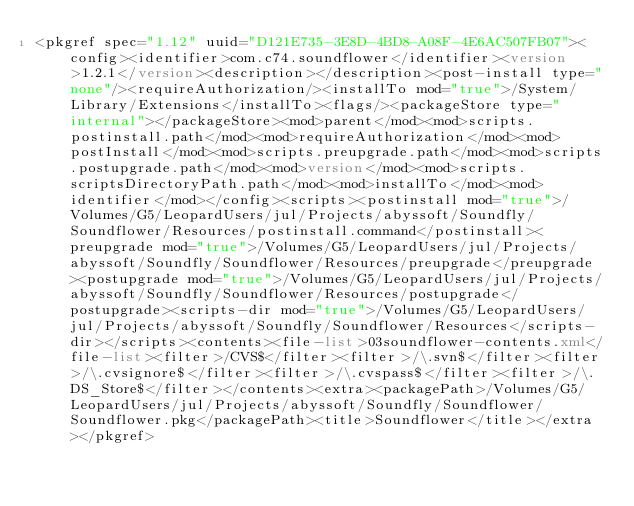<code> <loc_0><loc_0><loc_500><loc_500><_XML_><pkgref spec="1.12" uuid="D121E735-3E8D-4BD8-A08F-4E6AC507FB07"><config><identifier>com.c74.soundflower</identifier><version>1.2.1</version><description></description><post-install type="none"/><requireAuthorization/><installTo mod="true">/System/Library/Extensions</installTo><flags/><packageStore type="internal"></packageStore><mod>parent</mod><mod>scripts.postinstall.path</mod><mod>requireAuthorization</mod><mod>postInstall</mod><mod>scripts.preupgrade.path</mod><mod>scripts.postupgrade.path</mod><mod>version</mod><mod>scripts.scriptsDirectoryPath.path</mod><mod>installTo</mod><mod>identifier</mod></config><scripts><postinstall mod="true">/Volumes/G5/LeopardUsers/jul/Projects/abyssoft/Soundfly/Soundflower/Resources/postinstall.command</postinstall><preupgrade mod="true">/Volumes/G5/LeopardUsers/jul/Projects/abyssoft/Soundfly/Soundflower/Resources/preupgrade</preupgrade><postupgrade mod="true">/Volumes/G5/LeopardUsers/jul/Projects/abyssoft/Soundfly/Soundflower/Resources/postupgrade</postupgrade><scripts-dir mod="true">/Volumes/G5/LeopardUsers/jul/Projects/abyssoft/Soundfly/Soundflower/Resources</scripts-dir></scripts><contents><file-list>03soundflower-contents.xml</file-list><filter>/CVS$</filter><filter>/\.svn$</filter><filter>/\.cvsignore$</filter><filter>/\.cvspass$</filter><filter>/\.DS_Store$</filter></contents><extra><packagePath>/Volumes/G5/LeopardUsers/jul/Projects/abyssoft/Soundfly/Soundflower/Soundflower.pkg</packagePath><title>Soundflower</title></extra></pkgref></code> 